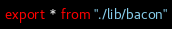<code> <loc_0><loc_0><loc_500><loc_500><_TypeScript_>export * from "./lib/bacon"
</code> 